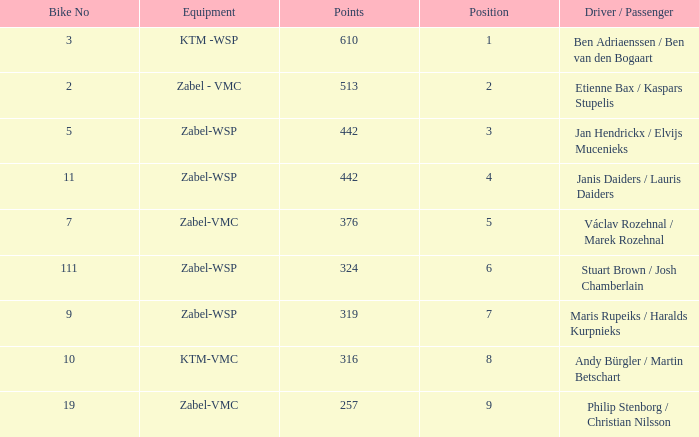What are the points for ktm-vmc equipment?  316.0. 